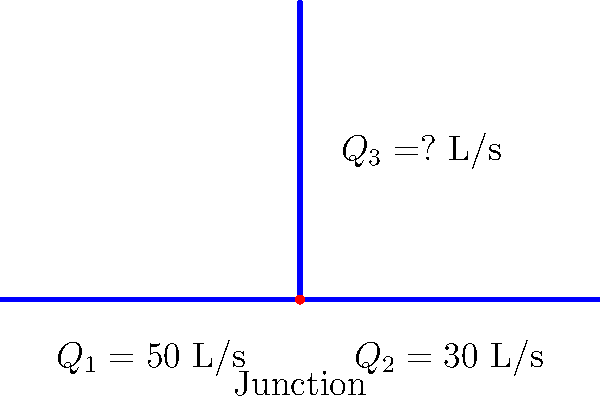In the given pipe network system, water flows from left to right in the main pipe and splits at the junction. If the flow rate in the left section of the main pipe ($Q_1$) is 50 L/s and the flow rate in the right section ($Q_2$) is 30 L/s, what is the flow rate in the vertical pipe ($Q_3$)? Assume steady-state conditions and no water loss in the system. To solve this problem, we'll use the principle of conservation of mass, which in the context of fluid dynamics translates to the continuity equation. For an incompressible fluid in steady-state conditions:

1. At the junction, the sum of all inflows must equal the sum of all outflows.

2. We can express this mathematically as:
   $$Q_1 = Q_2 + Q_3$$

3. We know the values of $Q_1$ and $Q_2$:
   $Q_1 = 50$ L/s
   $Q_2 = 30$ L/s

4. Substituting these values into our equation:
   $$50 = 30 + Q_3$$

5. Solving for $Q_3$:
   $$Q_3 = 50 - 30 = 20$$ L/s

Therefore, the flow rate in the vertical pipe ($Q_3$) is 20 L/s.

This analysis demonstrates the application of basic fluid dynamics principles in a simple pipe network, illustrating how flow rates are balanced in a system to maintain continuity.
Answer: 20 L/s 